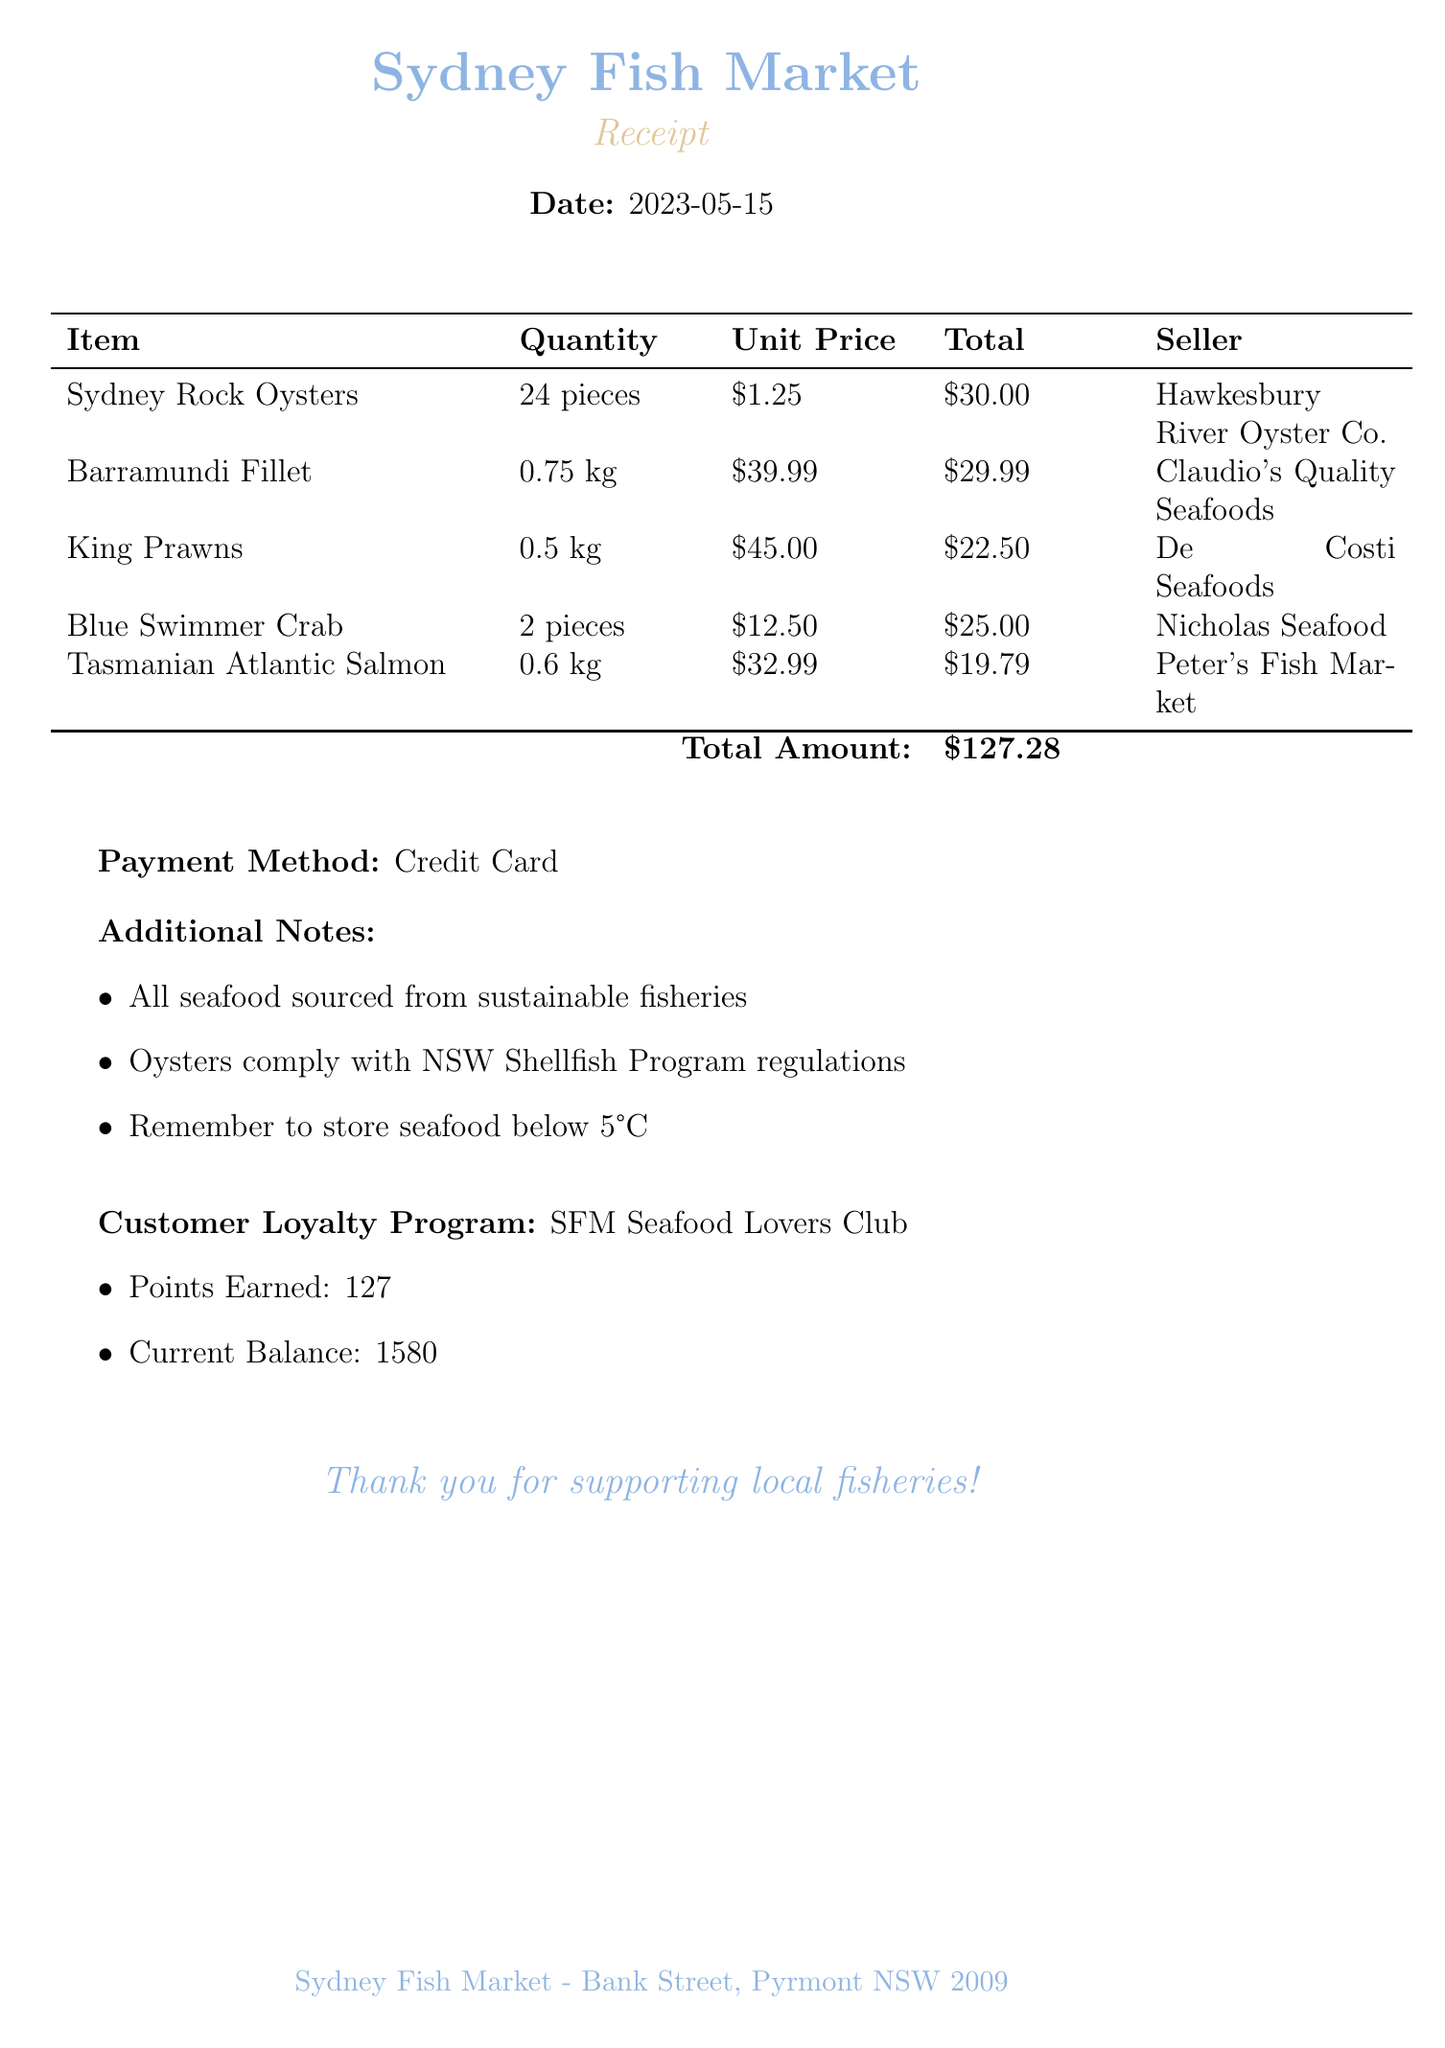What is the date of the purchase? The date is clearly stated in the document, specifying when the transaction occurred.
Answer: 2023-05-15 What is the total amount spent? The total amount is presented at the end of the itemized list, representing the total cost of all items purchased.
Answer: $127.28 Who sold the Sydney Rock Oysters? The seller's name for the oysters is indicated next to the item in the receipt.
Answer: Hawkesbury River Oyster Co How many pieces of Blue Swimmer Crab were purchased? The quantity for the Blue Swimmer Crab is listed next to the item description in the receipt.
Answer: 2 pieces What is the price per kilogram of Barramundi Fillet? The unit price for the Barramundi Fillet is specified in the table, indicating the cost per kilogram.
Answer: $39.99 What loyalty program is mentioned in the receipt? The document names the loyalty program as part of the customer incentives section.
Answer: SFM Seafood Lovers Club How many points were earned from this purchase? The points earned from the transaction are listed under the customer loyalty program section.
Answer: 127 What is the storage instruction for seafood? The receipt includes additional notes, which provide guidance on proper storage for seafood.
Answer: Below 5°C Which seafood item was sold by Peter's Fish Market? The seller's name for the item is shown alongside each product listed in the receipt.
Answer: Tasmanian Atlantic Salmon 